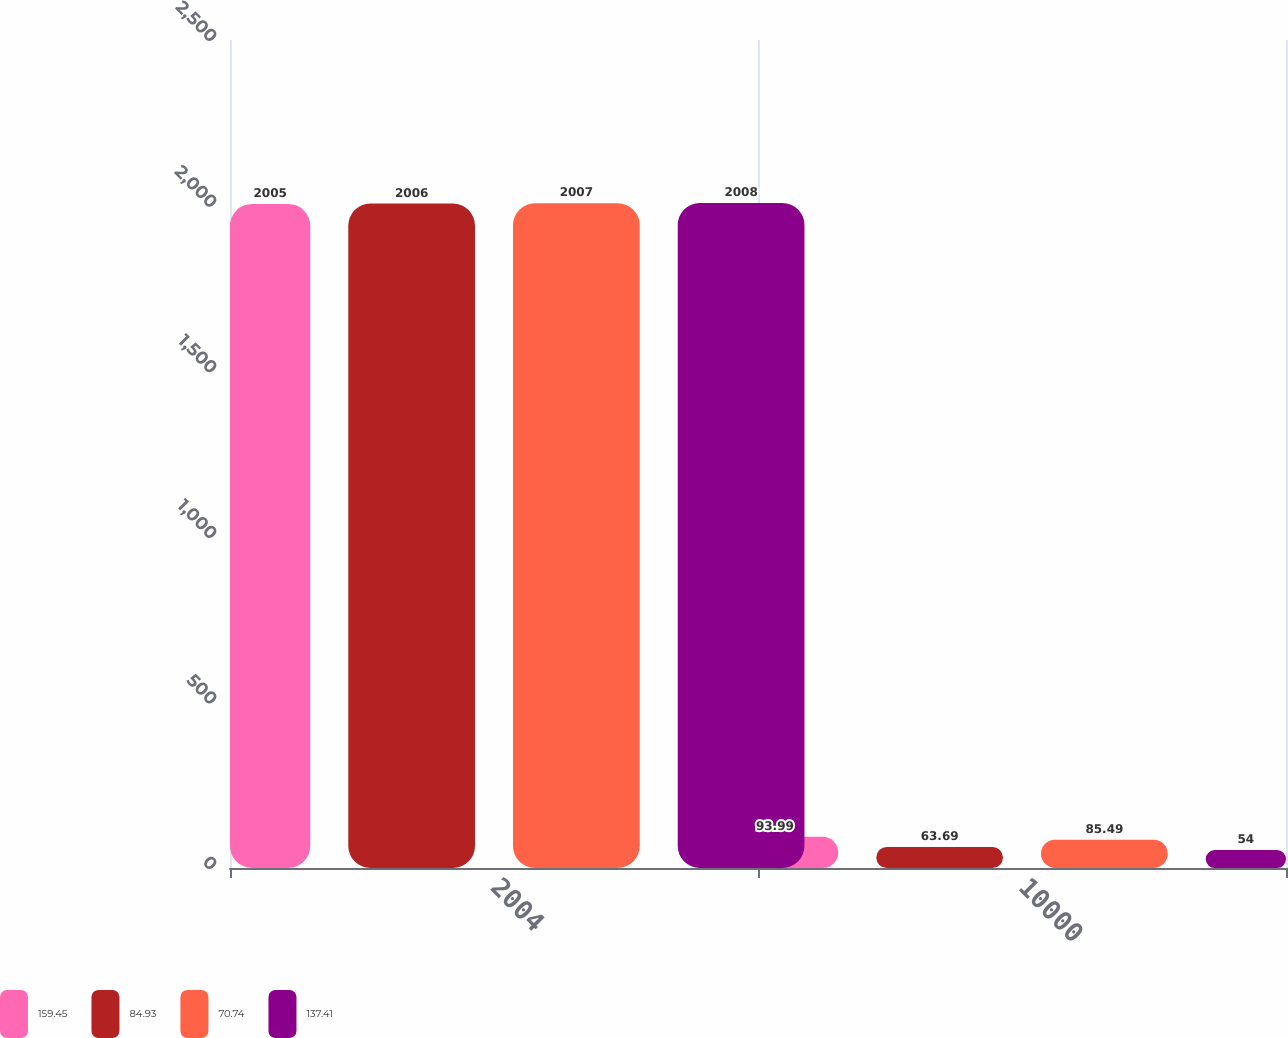Convert chart to OTSL. <chart><loc_0><loc_0><loc_500><loc_500><stacked_bar_chart><ecel><fcel>2004<fcel>10000<nl><fcel>159.45<fcel>2005<fcel>93.99<nl><fcel>84.93<fcel>2006<fcel>63.69<nl><fcel>70.74<fcel>2007<fcel>85.49<nl><fcel>137.41<fcel>2008<fcel>54<nl></chart> 